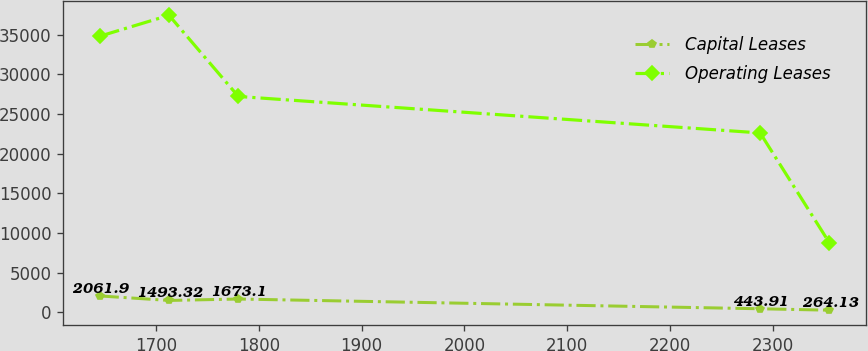Convert chart to OTSL. <chart><loc_0><loc_0><loc_500><loc_500><line_chart><ecel><fcel>Capital Leases<fcel>Operating Leases<nl><fcel>1645.22<fcel>2061.9<fcel>34814.3<nl><fcel>1712.69<fcel>1493.32<fcel>37454.4<nl><fcel>1780.16<fcel>1673.1<fcel>27218.8<nl><fcel>2287.71<fcel>443.91<fcel>22621.1<nl><fcel>2355.18<fcel>264.13<fcel>8743.94<nl></chart> 